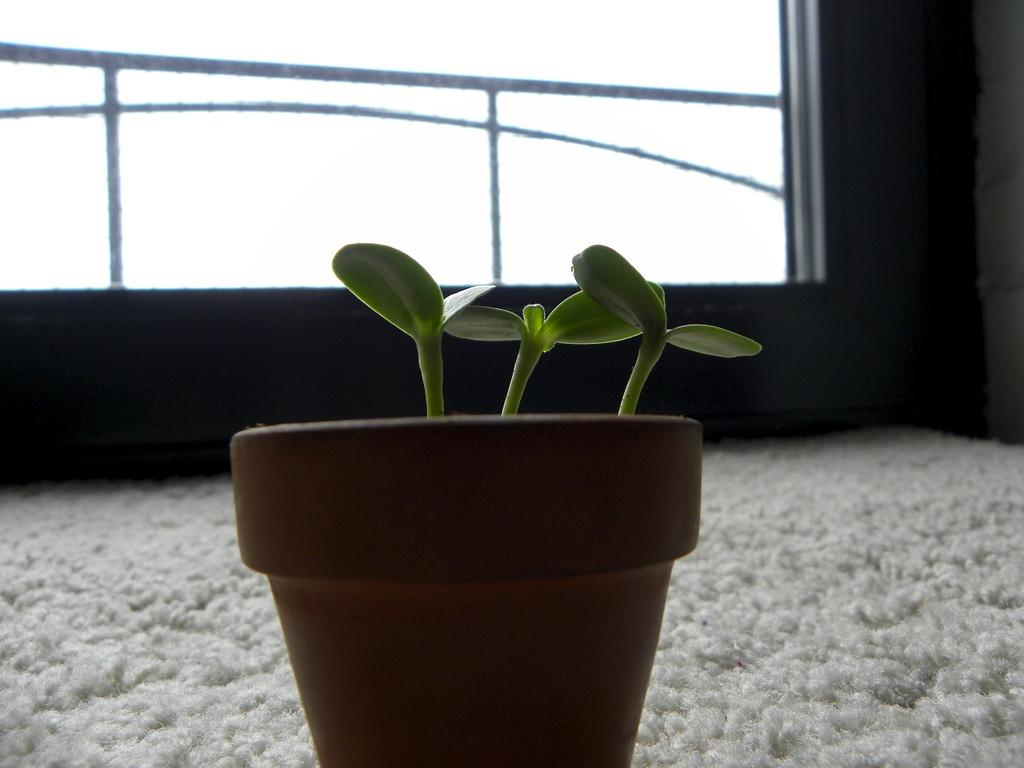What type of plant is in the flower pot in the image? The facts do not specify the type of plant in the flower pot. What is at the bottom of the image? There is a carpet at the bottom of the image. What can be seen in the background of the image? There is a wall in the background of the image. What feature is present in the image that might be used for support or safety? There is a railing in the image. What is the tendency of the horn in the image? There is no horn present in the image. 